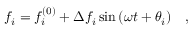Convert formula to latex. <formula><loc_0><loc_0><loc_500><loc_500>f _ { i } = f _ { i } ^ { ( 0 ) } + \Delta f _ { i } \sin { ( \omega t + \theta _ { i } ) } \quad ,</formula> 